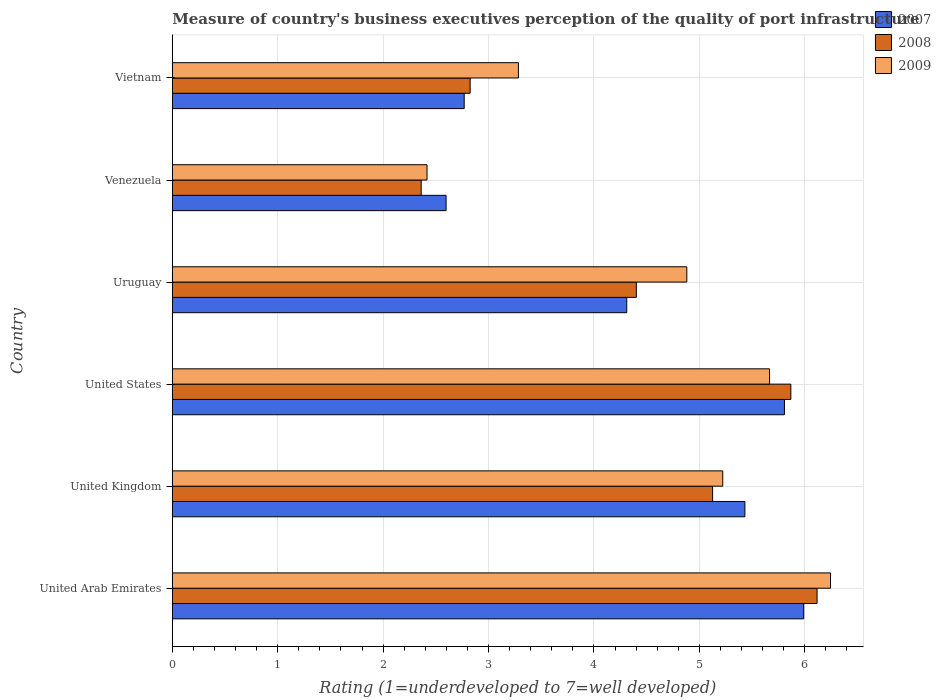Are the number of bars per tick equal to the number of legend labels?
Provide a short and direct response. Yes. How many bars are there on the 4th tick from the top?
Give a very brief answer. 3. How many bars are there on the 4th tick from the bottom?
Provide a short and direct response. 3. What is the label of the 1st group of bars from the top?
Ensure brevity in your answer.  Vietnam. In how many cases, is the number of bars for a given country not equal to the number of legend labels?
Give a very brief answer. 0. What is the ratings of the quality of port infrastructure in 2008 in United Kingdom?
Provide a succinct answer. 5.13. Across all countries, what is the maximum ratings of the quality of port infrastructure in 2009?
Provide a short and direct response. 6.24. Across all countries, what is the minimum ratings of the quality of port infrastructure in 2007?
Your answer should be compact. 2.6. In which country was the ratings of the quality of port infrastructure in 2008 maximum?
Your answer should be very brief. United Arab Emirates. In which country was the ratings of the quality of port infrastructure in 2008 minimum?
Your response must be concise. Venezuela. What is the total ratings of the quality of port infrastructure in 2009 in the graph?
Provide a short and direct response. 27.72. What is the difference between the ratings of the quality of port infrastructure in 2007 in United Kingdom and that in Uruguay?
Offer a very short reply. 1.12. What is the difference between the ratings of the quality of port infrastructure in 2008 in United Kingdom and the ratings of the quality of port infrastructure in 2007 in United Arab Emirates?
Make the answer very short. -0.86. What is the average ratings of the quality of port infrastructure in 2008 per country?
Your answer should be compact. 4.45. What is the difference between the ratings of the quality of port infrastructure in 2007 and ratings of the quality of port infrastructure in 2008 in Uruguay?
Provide a short and direct response. -0.09. In how many countries, is the ratings of the quality of port infrastructure in 2009 greater than 3 ?
Ensure brevity in your answer.  5. What is the ratio of the ratings of the quality of port infrastructure in 2009 in United Arab Emirates to that in Uruguay?
Ensure brevity in your answer.  1.28. What is the difference between the highest and the second highest ratings of the quality of port infrastructure in 2008?
Offer a terse response. 0.25. What is the difference between the highest and the lowest ratings of the quality of port infrastructure in 2008?
Offer a terse response. 3.76. Is the sum of the ratings of the quality of port infrastructure in 2008 in United States and Venezuela greater than the maximum ratings of the quality of port infrastructure in 2007 across all countries?
Offer a very short reply. Yes. What does the 1st bar from the top in Vietnam represents?
Your response must be concise. 2009. What does the 3rd bar from the bottom in United Arab Emirates represents?
Provide a succinct answer. 2009. Is it the case that in every country, the sum of the ratings of the quality of port infrastructure in 2008 and ratings of the quality of port infrastructure in 2007 is greater than the ratings of the quality of port infrastructure in 2009?
Your response must be concise. Yes. How many bars are there?
Keep it short and to the point. 18. How many countries are there in the graph?
Your answer should be very brief. 6. Are the values on the major ticks of X-axis written in scientific E-notation?
Your answer should be compact. No. Does the graph contain any zero values?
Keep it short and to the point. No. Does the graph contain grids?
Offer a terse response. Yes. How many legend labels are there?
Ensure brevity in your answer.  3. How are the legend labels stacked?
Your answer should be very brief. Vertical. What is the title of the graph?
Make the answer very short. Measure of country's business executives perception of the quality of port infrastructure. What is the label or title of the X-axis?
Keep it short and to the point. Rating (1=underdeveloped to 7=well developed). What is the Rating (1=underdeveloped to 7=well developed) of 2007 in United Arab Emirates?
Provide a short and direct response. 5.99. What is the Rating (1=underdeveloped to 7=well developed) of 2008 in United Arab Emirates?
Provide a short and direct response. 6.12. What is the Rating (1=underdeveloped to 7=well developed) of 2009 in United Arab Emirates?
Your response must be concise. 6.24. What is the Rating (1=underdeveloped to 7=well developed) in 2007 in United Kingdom?
Keep it short and to the point. 5.43. What is the Rating (1=underdeveloped to 7=well developed) of 2008 in United Kingdom?
Your answer should be very brief. 5.13. What is the Rating (1=underdeveloped to 7=well developed) in 2009 in United Kingdom?
Keep it short and to the point. 5.22. What is the Rating (1=underdeveloped to 7=well developed) of 2007 in United States?
Your response must be concise. 5.81. What is the Rating (1=underdeveloped to 7=well developed) of 2008 in United States?
Give a very brief answer. 5.87. What is the Rating (1=underdeveloped to 7=well developed) of 2009 in United States?
Your answer should be compact. 5.67. What is the Rating (1=underdeveloped to 7=well developed) of 2007 in Uruguay?
Provide a short and direct response. 4.31. What is the Rating (1=underdeveloped to 7=well developed) of 2008 in Uruguay?
Give a very brief answer. 4.4. What is the Rating (1=underdeveloped to 7=well developed) of 2009 in Uruguay?
Offer a very short reply. 4.88. What is the Rating (1=underdeveloped to 7=well developed) in 2007 in Venezuela?
Offer a terse response. 2.6. What is the Rating (1=underdeveloped to 7=well developed) in 2008 in Venezuela?
Offer a terse response. 2.36. What is the Rating (1=underdeveloped to 7=well developed) of 2009 in Venezuela?
Provide a succinct answer. 2.42. What is the Rating (1=underdeveloped to 7=well developed) in 2007 in Vietnam?
Keep it short and to the point. 2.77. What is the Rating (1=underdeveloped to 7=well developed) of 2008 in Vietnam?
Your answer should be compact. 2.83. What is the Rating (1=underdeveloped to 7=well developed) in 2009 in Vietnam?
Make the answer very short. 3.28. Across all countries, what is the maximum Rating (1=underdeveloped to 7=well developed) of 2007?
Make the answer very short. 5.99. Across all countries, what is the maximum Rating (1=underdeveloped to 7=well developed) of 2008?
Your response must be concise. 6.12. Across all countries, what is the maximum Rating (1=underdeveloped to 7=well developed) in 2009?
Your answer should be very brief. 6.24. Across all countries, what is the minimum Rating (1=underdeveloped to 7=well developed) of 2007?
Your response must be concise. 2.6. Across all countries, what is the minimum Rating (1=underdeveloped to 7=well developed) in 2008?
Your answer should be very brief. 2.36. Across all countries, what is the minimum Rating (1=underdeveloped to 7=well developed) in 2009?
Provide a succinct answer. 2.42. What is the total Rating (1=underdeveloped to 7=well developed) of 2007 in the graph?
Provide a succinct answer. 26.91. What is the total Rating (1=underdeveloped to 7=well developed) of 2008 in the graph?
Your answer should be compact. 26.7. What is the total Rating (1=underdeveloped to 7=well developed) of 2009 in the graph?
Provide a succinct answer. 27.72. What is the difference between the Rating (1=underdeveloped to 7=well developed) in 2007 in United Arab Emirates and that in United Kingdom?
Offer a terse response. 0.56. What is the difference between the Rating (1=underdeveloped to 7=well developed) in 2008 in United Arab Emirates and that in United Kingdom?
Offer a very short reply. 0.99. What is the difference between the Rating (1=underdeveloped to 7=well developed) in 2009 in United Arab Emirates and that in United Kingdom?
Your answer should be very brief. 1.02. What is the difference between the Rating (1=underdeveloped to 7=well developed) in 2007 in United Arab Emirates and that in United States?
Give a very brief answer. 0.18. What is the difference between the Rating (1=underdeveloped to 7=well developed) in 2008 in United Arab Emirates and that in United States?
Offer a terse response. 0.25. What is the difference between the Rating (1=underdeveloped to 7=well developed) of 2009 in United Arab Emirates and that in United States?
Your answer should be compact. 0.58. What is the difference between the Rating (1=underdeveloped to 7=well developed) in 2007 in United Arab Emirates and that in Uruguay?
Provide a short and direct response. 1.68. What is the difference between the Rating (1=underdeveloped to 7=well developed) in 2008 in United Arab Emirates and that in Uruguay?
Provide a short and direct response. 1.71. What is the difference between the Rating (1=underdeveloped to 7=well developed) of 2009 in United Arab Emirates and that in Uruguay?
Give a very brief answer. 1.36. What is the difference between the Rating (1=underdeveloped to 7=well developed) of 2007 in United Arab Emirates and that in Venezuela?
Give a very brief answer. 3.39. What is the difference between the Rating (1=underdeveloped to 7=well developed) of 2008 in United Arab Emirates and that in Venezuela?
Make the answer very short. 3.76. What is the difference between the Rating (1=underdeveloped to 7=well developed) of 2009 in United Arab Emirates and that in Venezuela?
Your response must be concise. 3.83. What is the difference between the Rating (1=underdeveloped to 7=well developed) in 2007 in United Arab Emirates and that in Vietnam?
Give a very brief answer. 3.22. What is the difference between the Rating (1=underdeveloped to 7=well developed) of 2008 in United Arab Emirates and that in Vietnam?
Offer a terse response. 3.29. What is the difference between the Rating (1=underdeveloped to 7=well developed) of 2009 in United Arab Emirates and that in Vietnam?
Give a very brief answer. 2.96. What is the difference between the Rating (1=underdeveloped to 7=well developed) in 2007 in United Kingdom and that in United States?
Keep it short and to the point. -0.38. What is the difference between the Rating (1=underdeveloped to 7=well developed) of 2008 in United Kingdom and that in United States?
Provide a succinct answer. -0.74. What is the difference between the Rating (1=underdeveloped to 7=well developed) of 2009 in United Kingdom and that in United States?
Ensure brevity in your answer.  -0.44. What is the difference between the Rating (1=underdeveloped to 7=well developed) of 2007 in United Kingdom and that in Uruguay?
Your answer should be very brief. 1.12. What is the difference between the Rating (1=underdeveloped to 7=well developed) in 2008 in United Kingdom and that in Uruguay?
Make the answer very short. 0.72. What is the difference between the Rating (1=underdeveloped to 7=well developed) of 2009 in United Kingdom and that in Uruguay?
Your response must be concise. 0.34. What is the difference between the Rating (1=underdeveloped to 7=well developed) of 2007 in United Kingdom and that in Venezuela?
Your answer should be very brief. 2.84. What is the difference between the Rating (1=underdeveloped to 7=well developed) in 2008 in United Kingdom and that in Venezuela?
Your answer should be very brief. 2.77. What is the difference between the Rating (1=underdeveloped to 7=well developed) of 2009 in United Kingdom and that in Venezuela?
Provide a short and direct response. 2.81. What is the difference between the Rating (1=underdeveloped to 7=well developed) of 2007 in United Kingdom and that in Vietnam?
Offer a very short reply. 2.66. What is the difference between the Rating (1=underdeveloped to 7=well developed) of 2008 in United Kingdom and that in Vietnam?
Ensure brevity in your answer.  2.3. What is the difference between the Rating (1=underdeveloped to 7=well developed) of 2009 in United Kingdom and that in Vietnam?
Provide a short and direct response. 1.94. What is the difference between the Rating (1=underdeveloped to 7=well developed) of 2007 in United States and that in Uruguay?
Your response must be concise. 1.5. What is the difference between the Rating (1=underdeveloped to 7=well developed) in 2008 in United States and that in Uruguay?
Make the answer very short. 1.47. What is the difference between the Rating (1=underdeveloped to 7=well developed) in 2009 in United States and that in Uruguay?
Give a very brief answer. 0.79. What is the difference between the Rating (1=underdeveloped to 7=well developed) of 2007 in United States and that in Venezuela?
Make the answer very short. 3.21. What is the difference between the Rating (1=underdeveloped to 7=well developed) of 2008 in United States and that in Venezuela?
Offer a very short reply. 3.51. What is the difference between the Rating (1=underdeveloped to 7=well developed) of 2009 in United States and that in Venezuela?
Your answer should be compact. 3.25. What is the difference between the Rating (1=underdeveloped to 7=well developed) in 2007 in United States and that in Vietnam?
Your answer should be very brief. 3.04. What is the difference between the Rating (1=underdeveloped to 7=well developed) of 2008 in United States and that in Vietnam?
Provide a succinct answer. 3.04. What is the difference between the Rating (1=underdeveloped to 7=well developed) in 2009 in United States and that in Vietnam?
Provide a short and direct response. 2.38. What is the difference between the Rating (1=underdeveloped to 7=well developed) in 2007 in Uruguay and that in Venezuela?
Your answer should be very brief. 1.71. What is the difference between the Rating (1=underdeveloped to 7=well developed) in 2008 in Uruguay and that in Venezuela?
Your answer should be very brief. 2.04. What is the difference between the Rating (1=underdeveloped to 7=well developed) of 2009 in Uruguay and that in Venezuela?
Offer a very short reply. 2.46. What is the difference between the Rating (1=underdeveloped to 7=well developed) in 2007 in Uruguay and that in Vietnam?
Ensure brevity in your answer.  1.54. What is the difference between the Rating (1=underdeveloped to 7=well developed) in 2008 in Uruguay and that in Vietnam?
Make the answer very short. 1.58. What is the difference between the Rating (1=underdeveloped to 7=well developed) of 2009 in Uruguay and that in Vietnam?
Provide a short and direct response. 1.6. What is the difference between the Rating (1=underdeveloped to 7=well developed) of 2007 in Venezuela and that in Vietnam?
Offer a terse response. -0.17. What is the difference between the Rating (1=underdeveloped to 7=well developed) in 2008 in Venezuela and that in Vietnam?
Keep it short and to the point. -0.46. What is the difference between the Rating (1=underdeveloped to 7=well developed) of 2009 in Venezuela and that in Vietnam?
Offer a very short reply. -0.87. What is the difference between the Rating (1=underdeveloped to 7=well developed) in 2007 in United Arab Emirates and the Rating (1=underdeveloped to 7=well developed) in 2008 in United Kingdom?
Provide a short and direct response. 0.86. What is the difference between the Rating (1=underdeveloped to 7=well developed) of 2007 in United Arab Emirates and the Rating (1=underdeveloped to 7=well developed) of 2009 in United Kingdom?
Make the answer very short. 0.77. What is the difference between the Rating (1=underdeveloped to 7=well developed) in 2008 in United Arab Emirates and the Rating (1=underdeveloped to 7=well developed) in 2009 in United Kingdom?
Provide a succinct answer. 0.89. What is the difference between the Rating (1=underdeveloped to 7=well developed) in 2007 in United Arab Emirates and the Rating (1=underdeveloped to 7=well developed) in 2008 in United States?
Your response must be concise. 0.12. What is the difference between the Rating (1=underdeveloped to 7=well developed) of 2007 in United Arab Emirates and the Rating (1=underdeveloped to 7=well developed) of 2009 in United States?
Make the answer very short. 0.32. What is the difference between the Rating (1=underdeveloped to 7=well developed) in 2008 in United Arab Emirates and the Rating (1=underdeveloped to 7=well developed) in 2009 in United States?
Provide a short and direct response. 0.45. What is the difference between the Rating (1=underdeveloped to 7=well developed) in 2007 in United Arab Emirates and the Rating (1=underdeveloped to 7=well developed) in 2008 in Uruguay?
Make the answer very short. 1.59. What is the difference between the Rating (1=underdeveloped to 7=well developed) of 2007 in United Arab Emirates and the Rating (1=underdeveloped to 7=well developed) of 2009 in Uruguay?
Offer a terse response. 1.11. What is the difference between the Rating (1=underdeveloped to 7=well developed) in 2008 in United Arab Emirates and the Rating (1=underdeveloped to 7=well developed) in 2009 in Uruguay?
Offer a terse response. 1.24. What is the difference between the Rating (1=underdeveloped to 7=well developed) of 2007 in United Arab Emirates and the Rating (1=underdeveloped to 7=well developed) of 2008 in Venezuela?
Your answer should be very brief. 3.63. What is the difference between the Rating (1=underdeveloped to 7=well developed) of 2007 in United Arab Emirates and the Rating (1=underdeveloped to 7=well developed) of 2009 in Venezuela?
Your response must be concise. 3.57. What is the difference between the Rating (1=underdeveloped to 7=well developed) of 2008 in United Arab Emirates and the Rating (1=underdeveloped to 7=well developed) of 2009 in Venezuela?
Provide a succinct answer. 3.7. What is the difference between the Rating (1=underdeveloped to 7=well developed) of 2007 in United Arab Emirates and the Rating (1=underdeveloped to 7=well developed) of 2008 in Vietnam?
Your answer should be very brief. 3.17. What is the difference between the Rating (1=underdeveloped to 7=well developed) in 2007 in United Arab Emirates and the Rating (1=underdeveloped to 7=well developed) in 2009 in Vietnam?
Give a very brief answer. 2.71. What is the difference between the Rating (1=underdeveloped to 7=well developed) of 2008 in United Arab Emirates and the Rating (1=underdeveloped to 7=well developed) of 2009 in Vietnam?
Offer a very short reply. 2.83. What is the difference between the Rating (1=underdeveloped to 7=well developed) in 2007 in United Kingdom and the Rating (1=underdeveloped to 7=well developed) in 2008 in United States?
Give a very brief answer. -0.44. What is the difference between the Rating (1=underdeveloped to 7=well developed) of 2007 in United Kingdom and the Rating (1=underdeveloped to 7=well developed) of 2009 in United States?
Ensure brevity in your answer.  -0.23. What is the difference between the Rating (1=underdeveloped to 7=well developed) in 2008 in United Kingdom and the Rating (1=underdeveloped to 7=well developed) in 2009 in United States?
Your response must be concise. -0.54. What is the difference between the Rating (1=underdeveloped to 7=well developed) in 2007 in United Kingdom and the Rating (1=underdeveloped to 7=well developed) in 2008 in Uruguay?
Offer a very short reply. 1.03. What is the difference between the Rating (1=underdeveloped to 7=well developed) in 2007 in United Kingdom and the Rating (1=underdeveloped to 7=well developed) in 2009 in Uruguay?
Keep it short and to the point. 0.55. What is the difference between the Rating (1=underdeveloped to 7=well developed) in 2008 in United Kingdom and the Rating (1=underdeveloped to 7=well developed) in 2009 in Uruguay?
Keep it short and to the point. 0.24. What is the difference between the Rating (1=underdeveloped to 7=well developed) in 2007 in United Kingdom and the Rating (1=underdeveloped to 7=well developed) in 2008 in Venezuela?
Ensure brevity in your answer.  3.07. What is the difference between the Rating (1=underdeveloped to 7=well developed) of 2007 in United Kingdom and the Rating (1=underdeveloped to 7=well developed) of 2009 in Venezuela?
Make the answer very short. 3.02. What is the difference between the Rating (1=underdeveloped to 7=well developed) in 2008 in United Kingdom and the Rating (1=underdeveloped to 7=well developed) in 2009 in Venezuela?
Provide a short and direct response. 2.71. What is the difference between the Rating (1=underdeveloped to 7=well developed) in 2007 in United Kingdom and the Rating (1=underdeveloped to 7=well developed) in 2008 in Vietnam?
Ensure brevity in your answer.  2.61. What is the difference between the Rating (1=underdeveloped to 7=well developed) in 2007 in United Kingdom and the Rating (1=underdeveloped to 7=well developed) in 2009 in Vietnam?
Give a very brief answer. 2.15. What is the difference between the Rating (1=underdeveloped to 7=well developed) in 2008 in United Kingdom and the Rating (1=underdeveloped to 7=well developed) in 2009 in Vietnam?
Offer a terse response. 1.84. What is the difference between the Rating (1=underdeveloped to 7=well developed) of 2007 in United States and the Rating (1=underdeveloped to 7=well developed) of 2008 in Uruguay?
Keep it short and to the point. 1.41. What is the difference between the Rating (1=underdeveloped to 7=well developed) of 2007 in United States and the Rating (1=underdeveloped to 7=well developed) of 2009 in Uruguay?
Your answer should be compact. 0.93. What is the difference between the Rating (1=underdeveloped to 7=well developed) of 2008 in United States and the Rating (1=underdeveloped to 7=well developed) of 2009 in Uruguay?
Give a very brief answer. 0.99. What is the difference between the Rating (1=underdeveloped to 7=well developed) of 2007 in United States and the Rating (1=underdeveloped to 7=well developed) of 2008 in Venezuela?
Your answer should be very brief. 3.45. What is the difference between the Rating (1=underdeveloped to 7=well developed) in 2007 in United States and the Rating (1=underdeveloped to 7=well developed) in 2009 in Venezuela?
Make the answer very short. 3.39. What is the difference between the Rating (1=underdeveloped to 7=well developed) in 2008 in United States and the Rating (1=underdeveloped to 7=well developed) in 2009 in Venezuela?
Offer a very short reply. 3.45. What is the difference between the Rating (1=underdeveloped to 7=well developed) of 2007 in United States and the Rating (1=underdeveloped to 7=well developed) of 2008 in Vietnam?
Offer a terse response. 2.98. What is the difference between the Rating (1=underdeveloped to 7=well developed) in 2007 in United States and the Rating (1=underdeveloped to 7=well developed) in 2009 in Vietnam?
Give a very brief answer. 2.52. What is the difference between the Rating (1=underdeveloped to 7=well developed) in 2008 in United States and the Rating (1=underdeveloped to 7=well developed) in 2009 in Vietnam?
Make the answer very short. 2.58. What is the difference between the Rating (1=underdeveloped to 7=well developed) in 2007 in Uruguay and the Rating (1=underdeveloped to 7=well developed) in 2008 in Venezuela?
Make the answer very short. 1.95. What is the difference between the Rating (1=underdeveloped to 7=well developed) of 2007 in Uruguay and the Rating (1=underdeveloped to 7=well developed) of 2009 in Venezuela?
Give a very brief answer. 1.9. What is the difference between the Rating (1=underdeveloped to 7=well developed) in 2008 in Uruguay and the Rating (1=underdeveloped to 7=well developed) in 2009 in Venezuela?
Your answer should be very brief. 1.99. What is the difference between the Rating (1=underdeveloped to 7=well developed) of 2007 in Uruguay and the Rating (1=underdeveloped to 7=well developed) of 2008 in Vietnam?
Make the answer very short. 1.49. What is the difference between the Rating (1=underdeveloped to 7=well developed) in 2007 in Uruguay and the Rating (1=underdeveloped to 7=well developed) in 2009 in Vietnam?
Make the answer very short. 1.03. What is the difference between the Rating (1=underdeveloped to 7=well developed) in 2008 in Uruguay and the Rating (1=underdeveloped to 7=well developed) in 2009 in Vietnam?
Offer a very short reply. 1.12. What is the difference between the Rating (1=underdeveloped to 7=well developed) in 2007 in Venezuela and the Rating (1=underdeveloped to 7=well developed) in 2008 in Vietnam?
Ensure brevity in your answer.  -0.23. What is the difference between the Rating (1=underdeveloped to 7=well developed) of 2007 in Venezuela and the Rating (1=underdeveloped to 7=well developed) of 2009 in Vietnam?
Provide a succinct answer. -0.69. What is the difference between the Rating (1=underdeveloped to 7=well developed) of 2008 in Venezuela and the Rating (1=underdeveloped to 7=well developed) of 2009 in Vietnam?
Your answer should be very brief. -0.92. What is the average Rating (1=underdeveloped to 7=well developed) of 2007 per country?
Your answer should be very brief. 4.48. What is the average Rating (1=underdeveloped to 7=well developed) in 2008 per country?
Your response must be concise. 4.45. What is the average Rating (1=underdeveloped to 7=well developed) of 2009 per country?
Make the answer very short. 4.62. What is the difference between the Rating (1=underdeveloped to 7=well developed) in 2007 and Rating (1=underdeveloped to 7=well developed) in 2008 in United Arab Emirates?
Ensure brevity in your answer.  -0.13. What is the difference between the Rating (1=underdeveloped to 7=well developed) of 2007 and Rating (1=underdeveloped to 7=well developed) of 2009 in United Arab Emirates?
Make the answer very short. -0.25. What is the difference between the Rating (1=underdeveloped to 7=well developed) of 2008 and Rating (1=underdeveloped to 7=well developed) of 2009 in United Arab Emirates?
Give a very brief answer. -0.13. What is the difference between the Rating (1=underdeveloped to 7=well developed) of 2007 and Rating (1=underdeveloped to 7=well developed) of 2008 in United Kingdom?
Your answer should be compact. 0.31. What is the difference between the Rating (1=underdeveloped to 7=well developed) in 2007 and Rating (1=underdeveloped to 7=well developed) in 2009 in United Kingdom?
Offer a terse response. 0.21. What is the difference between the Rating (1=underdeveloped to 7=well developed) in 2008 and Rating (1=underdeveloped to 7=well developed) in 2009 in United Kingdom?
Make the answer very short. -0.1. What is the difference between the Rating (1=underdeveloped to 7=well developed) in 2007 and Rating (1=underdeveloped to 7=well developed) in 2008 in United States?
Provide a succinct answer. -0.06. What is the difference between the Rating (1=underdeveloped to 7=well developed) in 2007 and Rating (1=underdeveloped to 7=well developed) in 2009 in United States?
Provide a succinct answer. 0.14. What is the difference between the Rating (1=underdeveloped to 7=well developed) in 2008 and Rating (1=underdeveloped to 7=well developed) in 2009 in United States?
Ensure brevity in your answer.  0.2. What is the difference between the Rating (1=underdeveloped to 7=well developed) of 2007 and Rating (1=underdeveloped to 7=well developed) of 2008 in Uruguay?
Ensure brevity in your answer.  -0.09. What is the difference between the Rating (1=underdeveloped to 7=well developed) of 2007 and Rating (1=underdeveloped to 7=well developed) of 2009 in Uruguay?
Make the answer very short. -0.57. What is the difference between the Rating (1=underdeveloped to 7=well developed) in 2008 and Rating (1=underdeveloped to 7=well developed) in 2009 in Uruguay?
Provide a succinct answer. -0.48. What is the difference between the Rating (1=underdeveloped to 7=well developed) in 2007 and Rating (1=underdeveloped to 7=well developed) in 2008 in Venezuela?
Your response must be concise. 0.24. What is the difference between the Rating (1=underdeveloped to 7=well developed) in 2007 and Rating (1=underdeveloped to 7=well developed) in 2009 in Venezuela?
Give a very brief answer. 0.18. What is the difference between the Rating (1=underdeveloped to 7=well developed) in 2008 and Rating (1=underdeveloped to 7=well developed) in 2009 in Venezuela?
Offer a very short reply. -0.06. What is the difference between the Rating (1=underdeveloped to 7=well developed) in 2007 and Rating (1=underdeveloped to 7=well developed) in 2008 in Vietnam?
Your answer should be compact. -0.06. What is the difference between the Rating (1=underdeveloped to 7=well developed) of 2007 and Rating (1=underdeveloped to 7=well developed) of 2009 in Vietnam?
Provide a short and direct response. -0.51. What is the difference between the Rating (1=underdeveloped to 7=well developed) in 2008 and Rating (1=underdeveloped to 7=well developed) in 2009 in Vietnam?
Provide a succinct answer. -0.46. What is the ratio of the Rating (1=underdeveloped to 7=well developed) of 2007 in United Arab Emirates to that in United Kingdom?
Offer a terse response. 1.1. What is the ratio of the Rating (1=underdeveloped to 7=well developed) of 2008 in United Arab Emirates to that in United Kingdom?
Keep it short and to the point. 1.19. What is the ratio of the Rating (1=underdeveloped to 7=well developed) in 2009 in United Arab Emirates to that in United Kingdom?
Keep it short and to the point. 1.2. What is the ratio of the Rating (1=underdeveloped to 7=well developed) in 2007 in United Arab Emirates to that in United States?
Offer a terse response. 1.03. What is the ratio of the Rating (1=underdeveloped to 7=well developed) of 2008 in United Arab Emirates to that in United States?
Ensure brevity in your answer.  1.04. What is the ratio of the Rating (1=underdeveloped to 7=well developed) of 2009 in United Arab Emirates to that in United States?
Provide a succinct answer. 1.1. What is the ratio of the Rating (1=underdeveloped to 7=well developed) in 2007 in United Arab Emirates to that in Uruguay?
Your answer should be very brief. 1.39. What is the ratio of the Rating (1=underdeveloped to 7=well developed) in 2008 in United Arab Emirates to that in Uruguay?
Provide a succinct answer. 1.39. What is the ratio of the Rating (1=underdeveloped to 7=well developed) in 2009 in United Arab Emirates to that in Uruguay?
Your answer should be compact. 1.28. What is the ratio of the Rating (1=underdeveloped to 7=well developed) of 2007 in United Arab Emirates to that in Venezuela?
Your answer should be compact. 2.31. What is the ratio of the Rating (1=underdeveloped to 7=well developed) of 2008 in United Arab Emirates to that in Venezuela?
Offer a very short reply. 2.59. What is the ratio of the Rating (1=underdeveloped to 7=well developed) in 2009 in United Arab Emirates to that in Venezuela?
Give a very brief answer. 2.58. What is the ratio of the Rating (1=underdeveloped to 7=well developed) in 2007 in United Arab Emirates to that in Vietnam?
Make the answer very short. 2.16. What is the ratio of the Rating (1=underdeveloped to 7=well developed) in 2008 in United Arab Emirates to that in Vietnam?
Keep it short and to the point. 2.16. What is the ratio of the Rating (1=underdeveloped to 7=well developed) in 2009 in United Arab Emirates to that in Vietnam?
Keep it short and to the point. 1.9. What is the ratio of the Rating (1=underdeveloped to 7=well developed) in 2007 in United Kingdom to that in United States?
Ensure brevity in your answer.  0.94. What is the ratio of the Rating (1=underdeveloped to 7=well developed) in 2008 in United Kingdom to that in United States?
Make the answer very short. 0.87. What is the ratio of the Rating (1=underdeveloped to 7=well developed) in 2009 in United Kingdom to that in United States?
Your response must be concise. 0.92. What is the ratio of the Rating (1=underdeveloped to 7=well developed) of 2007 in United Kingdom to that in Uruguay?
Make the answer very short. 1.26. What is the ratio of the Rating (1=underdeveloped to 7=well developed) of 2008 in United Kingdom to that in Uruguay?
Ensure brevity in your answer.  1.16. What is the ratio of the Rating (1=underdeveloped to 7=well developed) of 2009 in United Kingdom to that in Uruguay?
Provide a succinct answer. 1.07. What is the ratio of the Rating (1=underdeveloped to 7=well developed) in 2007 in United Kingdom to that in Venezuela?
Offer a terse response. 2.09. What is the ratio of the Rating (1=underdeveloped to 7=well developed) in 2008 in United Kingdom to that in Venezuela?
Ensure brevity in your answer.  2.17. What is the ratio of the Rating (1=underdeveloped to 7=well developed) in 2009 in United Kingdom to that in Venezuela?
Offer a terse response. 2.16. What is the ratio of the Rating (1=underdeveloped to 7=well developed) in 2007 in United Kingdom to that in Vietnam?
Provide a succinct answer. 1.96. What is the ratio of the Rating (1=underdeveloped to 7=well developed) in 2008 in United Kingdom to that in Vietnam?
Offer a terse response. 1.81. What is the ratio of the Rating (1=underdeveloped to 7=well developed) in 2009 in United Kingdom to that in Vietnam?
Provide a short and direct response. 1.59. What is the ratio of the Rating (1=underdeveloped to 7=well developed) of 2007 in United States to that in Uruguay?
Provide a succinct answer. 1.35. What is the ratio of the Rating (1=underdeveloped to 7=well developed) in 2008 in United States to that in Uruguay?
Offer a very short reply. 1.33. What is the ratio of the Rating (1=underdeveloped to 7=well developed) of 2009 in United States to that in Uruguay?
Provide a succinct answer. 1.16. What is the ratio of the Rating (1=underdeveloped to 7=well developed) of 2007 in United States to that in Venezuela?
Ensure brevity in your answer.  2.24. What is the ratio of the Rating (1=underdeveloped to 7=well developed) in 2008 in United States to that in Venezuela?
Make the answer very short. 2.49. What is the ratio of the Rating (1=underdeveloped to 7=well developed) of 2009 in United States to that in Venezuela?
Offer a terse response. 2.35. What is the ratio of the Rating (1=underdeveloped to 7=well developed) in 2007 in United States to that in Vietnam?
Your answer should be very brief. 2.1. What is the ratio of the Rating (1=underdeveloped to 7=well developed) of 2008 in United States to that in Vietnam?
Your answer should be very brief. 2.08. What is the ratio of the Rating (1=underdeveloped to 7=well developed) of 2009 in United States to that in Vietnam?
Make the answer very short. 1.73. What is the ratio of the Rating (1=underdeveloped to 7=well developed) in 2007 in Uruguay to that in Venezuela?
Give a very brief answer. 1.66. What is the ratio of the Rating (1=underdeveloped to 7=well developed) of 2008 in Uruguay to that in Venezuela?
Your answer should be compact. 1.86. What is the ratio of the Rating (1=underdeveloped to 7=well developed) of 2009 in Uruguay to that in Venezuela?
Your answer should be very brief. 2.02. What is the ratio of the Rating (1=underdeveloped to 7=well developed) of 2007 in Uruguay to that in Vietnam?
Offer a very short reply. 1.56. What is the ratio of the Rating (1=underdeveloped to 7=well developed) of 2008 in Uruguay to that in Vietnam?
Your answer should be compact. 1.56. What is the ratio of the Rating (1=underdeveloped to 7=well developed) of 2009 in Uruguay to that in Vietnam?
Your answer should be very brief. 1.49. What is the ratio of the Rating (1=underdeveloped to 7=well developed) of 2007 in Venezuela to that in Vietnam?
Your response must be concise. 0.94. What is the ratio of the Rating (1=underdeveloped to 7=well developed) in 2008 in Venezuela to that in Vietnam?
Your response must be concise. 0.84. What is the ratio of the Rating (1=underdeveloped to 7=well developed) in 2009 in Venezuela to that in Vietnam?
Make the answer very short. 0.74. What is the difference between the highest and the second highest Rating (1=underdeveloped to 7=well developed) in 2007?
Give a very brief answer. 0.18. What is the difference between the highest and the second highest Rating (1=underdeveloped to 7=well developed) of 2008?
Your answer should be compact. 0.25. What is the difference between the highest and the second highest Rating (1=underdeveloped to 7=well developed) in 2009?
Your answer should be compact. 0.58. What is the difference between the highest and the lowest Rating (1=underdeveloped to 7=well developed) in 2007?
Ensure brevity in your answer.  3.39. What is the difference between the highest and the lowest Rating (1=underdeveloped to 7=well developed) of 2008?
Give a very brief answer. 3.76. What is the difference between the highest and the lowest Rating (1=underdeveloped to 7=well developed) in 2009?
Give a very brief answer. 3.83. 